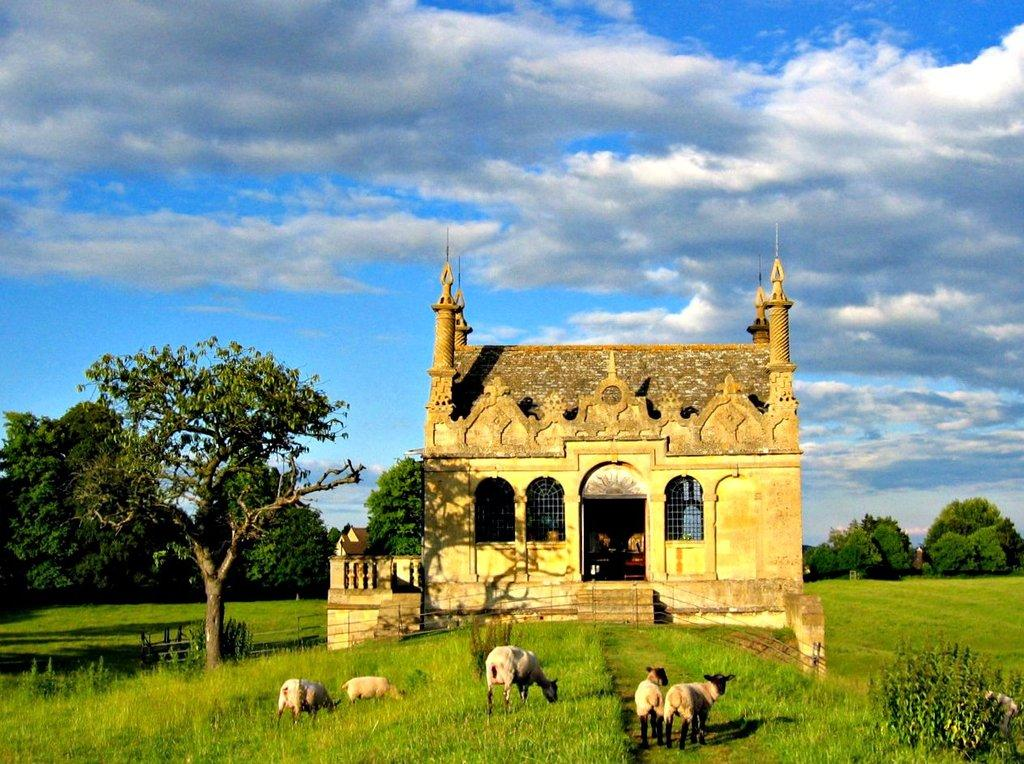How many animals are in the image? There are five animals in the image. Where are the animals located? The animals are on the grass. What other natural elements can be seen in the image? There are plants, trees, and the sky visible in the image. What type of structure is present in the image? There is a building in the image. Are there any objects in the image besides the animals and the building? Yes, there are some objects in the image. What type of fan is being used by the bird in the image? There is no bird or fan present in the image. Is the image based on a fictional story or event? The image does not appear to be based on a fictional story or event; it depicts a scene with animals, plants, and a building. 